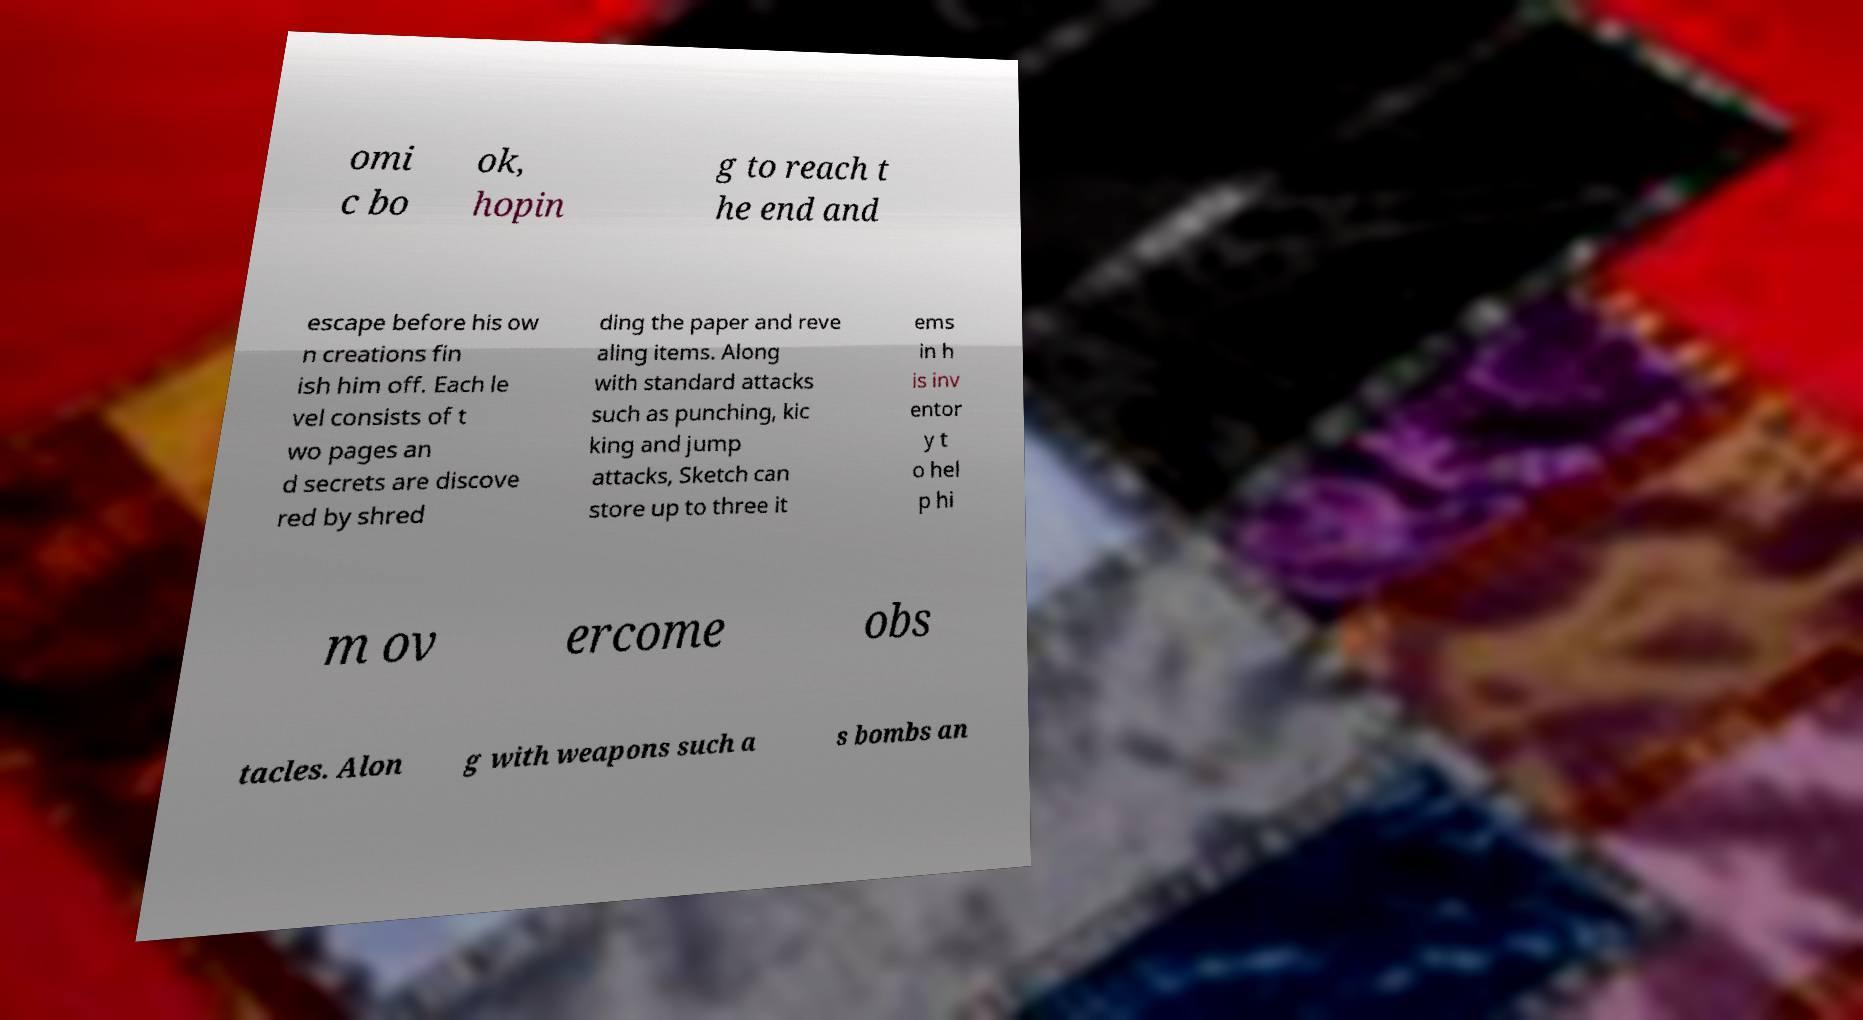Please read and relay the text visible in this image. What does it say? omi c bo ok, hopin g to reach t he end and escape before his ow n creations fin ish him off. Each le vel consists of t wo pages an d secrets are discove red by shred ding the paper and reve aling items. Along with standard attacks such as punching, kic king and jump attacks, Sketch can store up to three it ems in h is inv entor y t o hel p hi m ov ercome obs tacles. Alon g with weapons such a s bombs an 